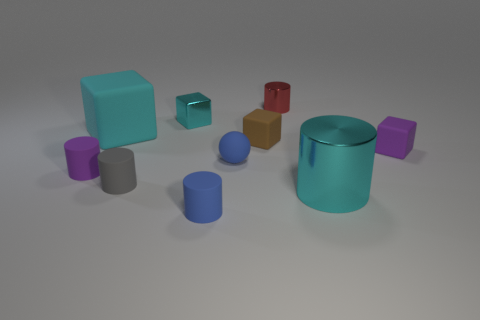The other shiny cube that is the same color as the large block is what size?
Provide a succinct answer. Small. There is a cyan object that is the same size as the purple cylinder; what material is it?
Your answer should be very brief. Metal. Are there any blue things in front of the tiny brown object?
Provide a succinct answer. Yes. Are there an equal number of small gray rubber things on the left side of the tiny gray cylinder and yellow shiny cylinders?
Your response must be concise. Yes. There is a cyan thing that is the same size as the brown object; what shape is it?
Your answer should be very brief. Cube. What is the red cylinder made of?
Your answer should be very brief. Metal. There is a rubber cube that is on the right side of the big cyan cube and left of the purple block; what is its color?
Your answer should be very brief. Brown. Is the number of large things left of the brown rubber block the same as the number of brown rubber things that are behind the tiny blue cylinder?
Your answer should be very brief. Yes. There is a big cube that is made of the same material as the small blue ball; what color is it?
Provide a succinct answer. Cyan. Does the metallic block have the same color as the small block right of the small red shiny cylinder?
Your answer should be compact. No. 